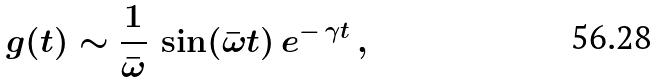Convert formula to latex. <formula><loc_0><loc_0><loc_500><loc_500>g ( t ) \sim \frac { 1 } { \bar { \omega } } \, \sin ( \bar { \omega } t ) \, e ^ { - \, \gamma t } \, ,</formula> 